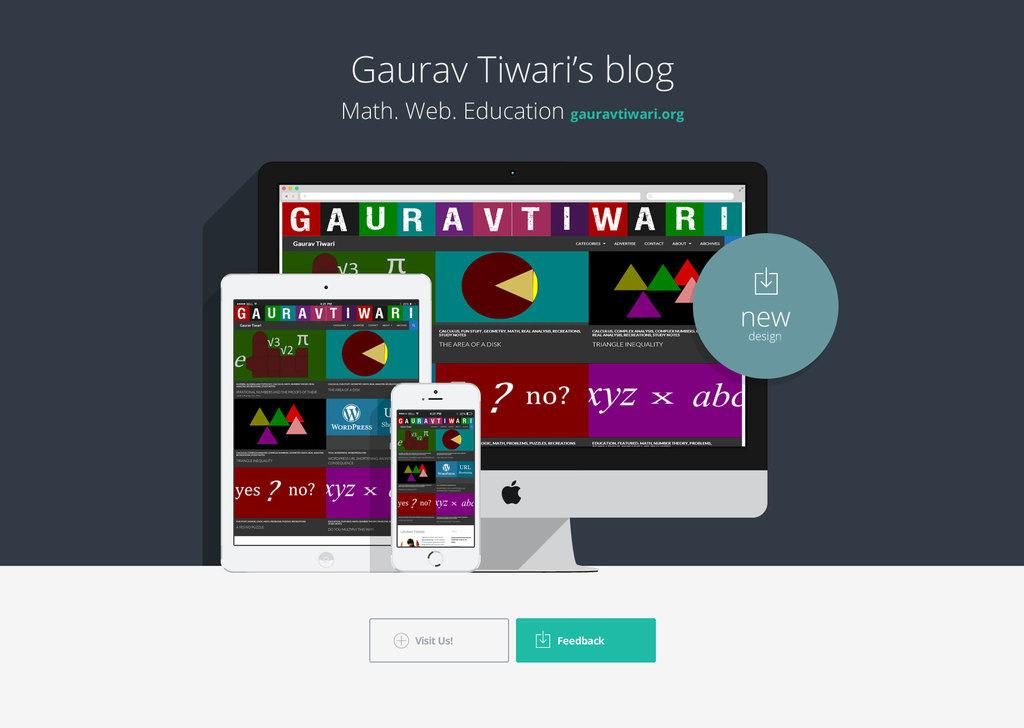<image>
Provide a brief description of the given image. A page entitled Gaurav Tiwari's blog with option to give feedback. 